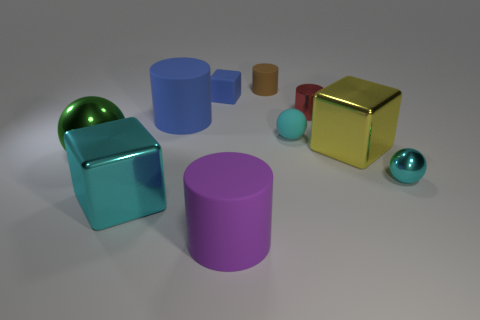How many cylinders are both to the right of the blue rubber cylinder and in front of the tiny rubber cylinder?
Your answer should be compact. 2. There is a tiny object in front of the large green metallic ball; what is its shape?
Your response must be concise. Sphere. Are there fewer big green shiny objects right of the big cyan thing than blue cylinders that are in front of the rubber sphere?
Your answer should be compact. No. Are the thing right of the yellow shiny object and the ball behind the big yellow block made of the same material?
Provide a succinct answer. No. What is the shape of the big blue matte object?
Offer a terse response. Cylinder. Are there more blue blocks in front of the big green sphere than big objects right of the large yellow metal cube?
Give a very brief answer. No. There is a green object to the left of the purple rubber thing; does it have the same shape as the tiny object that is to the left of the brown matte cylinder?
Keep it short and to the point. No. What number of other things are the same size as the blue cube?
Keep it short and to the point. 4. The cyan matte ball has what size?
Provide a short and direct response. Small. Is the material of the big cylinder that is behind the large green metal sphere the same as the big green sphere?
Make the answer very short. No. 